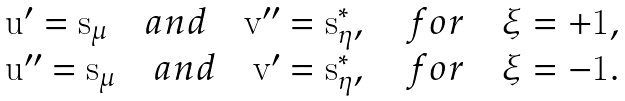Convert formula to latex. <formula><loc_0><loc_0><loc_500><loc_500>\begin{array} { l } \mathbf u ^ { \prime } = \mathbf s _ { \mu } \quad a n d \quad \mathbf v ^ { \prime \prime } = \mathbf s _ { \eta } ^ { * } , \quad f o r \quad \xi = + 1 , \\ \mathbf u ^ { \prime \prime } = \mathbf s _ { \mu } \quad a n d \quad \mathbf v ^ { \prime } = \mathbf s _ { \eta } ^ { * } , \quad f o r \quad \xi = - 1 . \end{array}</formula> 